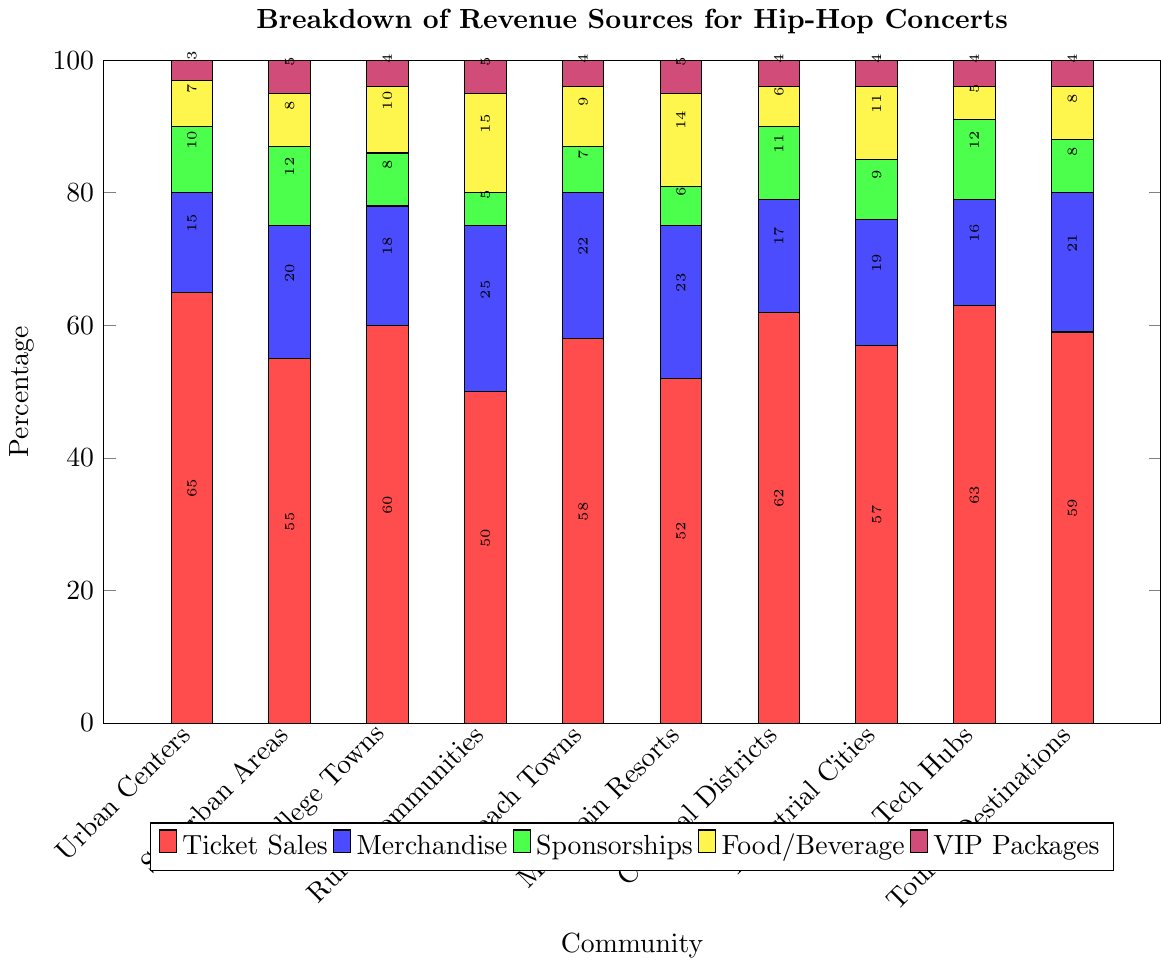Which community has the highest percentage of revenue from ticket sales? The tallest red bar represents the revenue from ticket sales. Among the communities, Urban Centers have the highest red bar at 65%.
Answer: Urban Centers What is the total percentage of revenue from merchandise and food/beverage in Beach Towns? The bar for merchandise in Beach Towns is 22%, and the bar for food/beverage is 9%. Adding these together gives 22% + 9% = 31%.
Answer: 31% How does the percentage of revenue from VIP Packages in Mountain Resorts compare to that in College Towns? The purple bar for VIP Packages in Mountain Resorts is 5%, whereas in College Towns it is 4%. Mountain Resorts have a 1% higher revenue from VIP Packages than College Towns.
Answer: Mountain Resorts have a higher percentage Which community has the lowest percentage of sponsorships? The shortest green bar represents sponsorships. Rural Communities have the shortest green bar at 5%.
Answer: Rural Communities What is the average percentage of ticket sales across all communities? Sum the percentages of ticket sales for all communities: 65 + 55 + 60 + 50 + 58 + 52 + 62 + 57 + 63 + 59 = 581. There are 10 communities, so divide by 10: 581 / 10 = 58.1%.
Answer: 58.1% What is the difference in the percentage of food/beverage revenue between Rural Communities and Tech Hubs? The yellow bar for food/beverage in Rural Communities is 15%, and in Tech Hubs, it is 5%. The difference is 15% - 5% = 10%.
Answer: 10% Which community has more revenue from merchandise: Suburban Areas or Mountain Resorts, and by how much? The blue bar for merchandise in Suburban Areas is 20% and in Mountain Resorts is 23%. Mountain Resorts have 3% more revenue from merchandise than Suburban Areas.
Answer: Mountain Resorts by 3% If you sum the percentage of revenue from VIP Packages in all communities, what is the total? Sum the percentages of VIP Packages across all communities: 3 + 5 + 4 + 5 + 4 + 5 + 4 + 4 + 4 + 4 = 42%.
Answer: 42% How does the revenue composition from sponsorships differ between Industrial Cities and Tourist Destinations? The green bar for sponsorships in Industrial Cities is 9%, while in Tourist Destinations it is 8%. Industrial Cities have a 1% higher sponsorship revenue than Tourist Destinations.
Answer: Industrial Cities have a higher percentage In which two communities is the revenue from ticket sales closest, and what is that percentage? The red bar for ticket sales in Cultural Districts is 62%, and in Tech Hubs, it is 63%, making these the closest with a 1% difference.
Answer: Cultural Districts and Tech Hubs, 62% and 63% respectively 